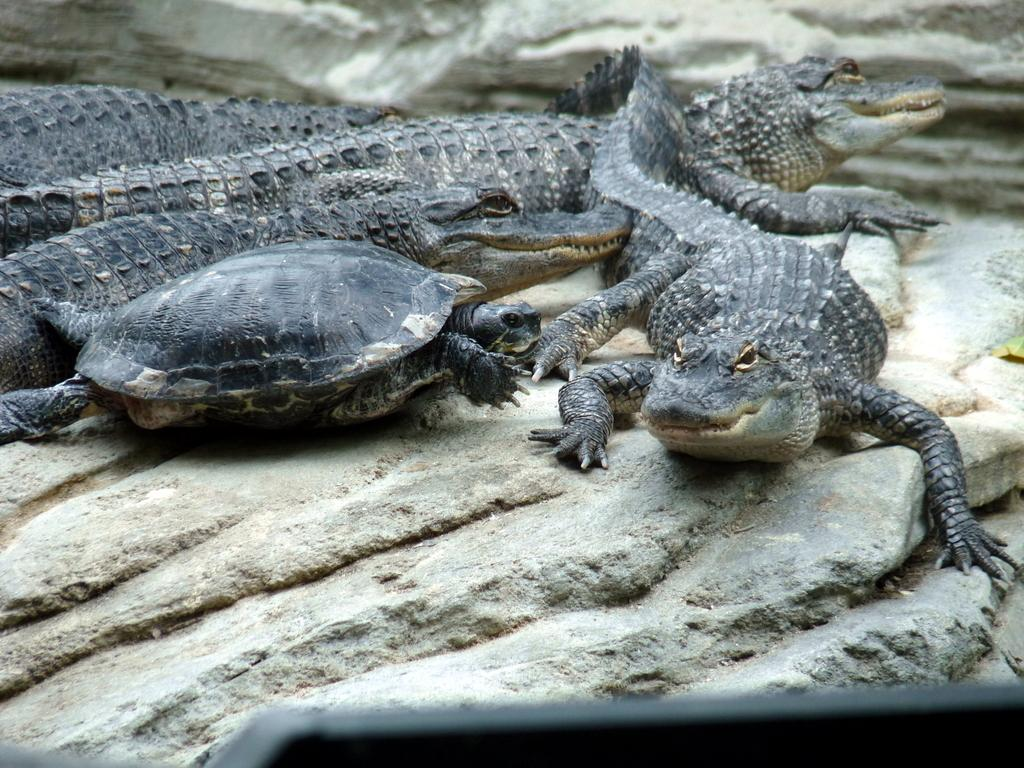What type of animals are present in the image? There are crocodiles and a turtle in the image. Can you describe the environment in the image? The image features a rock in the background. What other objects or animals might be present in the image? Based on the provided facts, there are no other objects or animals mentioned. How does the window in the image provide ventilation for the crocodiles? There is no window present in the image; it features crocodiles, a turtle, and a rock in the background. 